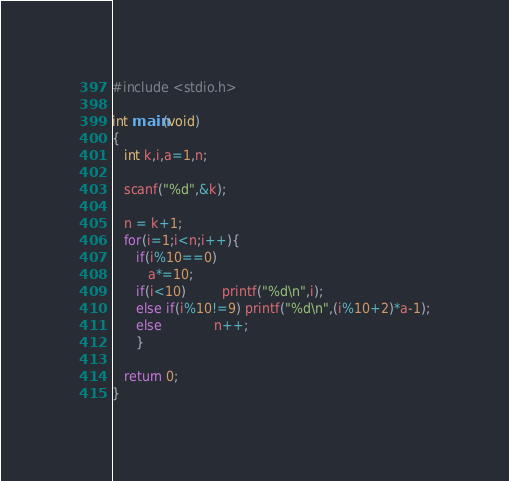Convert code to text. <code><loc_0><loc_0><loc_500><loc_500><_C_>#include <stdio.h>

int main(void)
{
   int k,i,a=1,n;

   scanf("%d",&k);

   n = k+1;
   for(i=1;i<n;i++){
      if(i%10==0)
         a*=10;
      if(i<10)         printf("%d\n",i);
      else if(i%10!=9) printf("%d\n",(i%10+2)*a-1);
      else             n++;
      }

   return 0;
}
</code> 